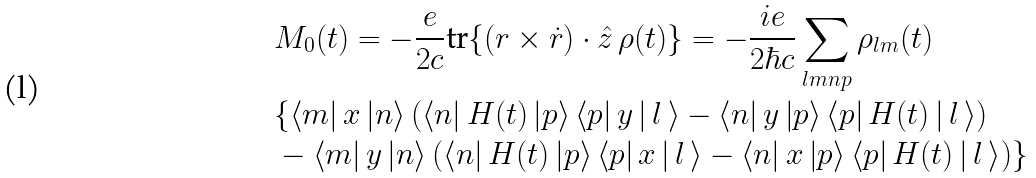<formula> <loc_0><loc_0><loc_500><loc_500>& M _ { 0 } ( t ) = - \frac { e } { 2 c } \text {tr} \{ ( { r } \times \dot { r } ) \cdot \hat { z } \, \rho ( t ) \} = - \frac { i e } { 2 \hbar { c } } \sum _ { l m n p } \rho _ { l m } ( t ) \\ & \{ \left < m \right | x \left | n \right > \left ( \left < n \right | H ( t ) \left | p \right > \left < p \right | y \left | \, l \, \right > - \left < n \right | y \left | p \right > \left < p \right | H ( t ) \left | \, l \, \right > \right ) \\ & - \left < m \right | y \left | n \right > \left ( \left < n \right | H ( t ) \left | p \right > \left < p \right | x \left | \, l \, \right > - \left < n \right | x \left | p \right > \left < p \right | H ( t ) \left | \, l \, \right > \right ) \}</formula> 